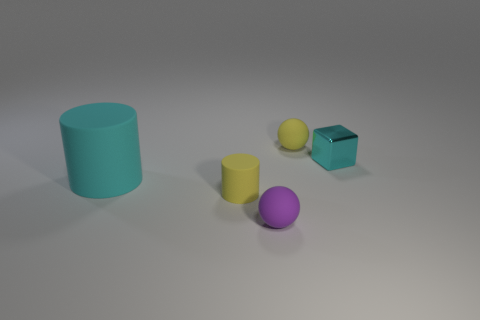Is there any other thing that has the same size as the cyan cylinder?
Offer a very short reply. No. There is another thing that is the same color as the tiny metallic thing; what is its size?
Your response must be concise. Large. What number of cyan objects are either metal cylinders or rubber cylinders?
Your answer should be very brief. 1. What is the shape of the metallic object to the right of the yellow object on the right side of the tiny ball that is in front of the cyan cube?
Provide a succinct answer. Cube. The shiny block that is the same size as the purple matte sphere is what color?
Make the answer very short. Cyan. What number of yellow objects have the same shape as the large cyan rubber thing?
Your response must be concise. 1. Does the shiny block have the same size as the cyan object left of the small purple ball?
Offer a very short reply. No. What shape is the yellow matte thing in front of the yellow thing that is right of the tiny yellow matte cylinder?
Your answer should be compact. Cylinder. Is the number of small yellow balls that are to the left of the purple sphere less than the number of blue metal balls?
Your answer should be compact. No. There is a small metallic thing that is the same color as the big cylinder; what is its shape?
Give a very brief answer. Cube. 